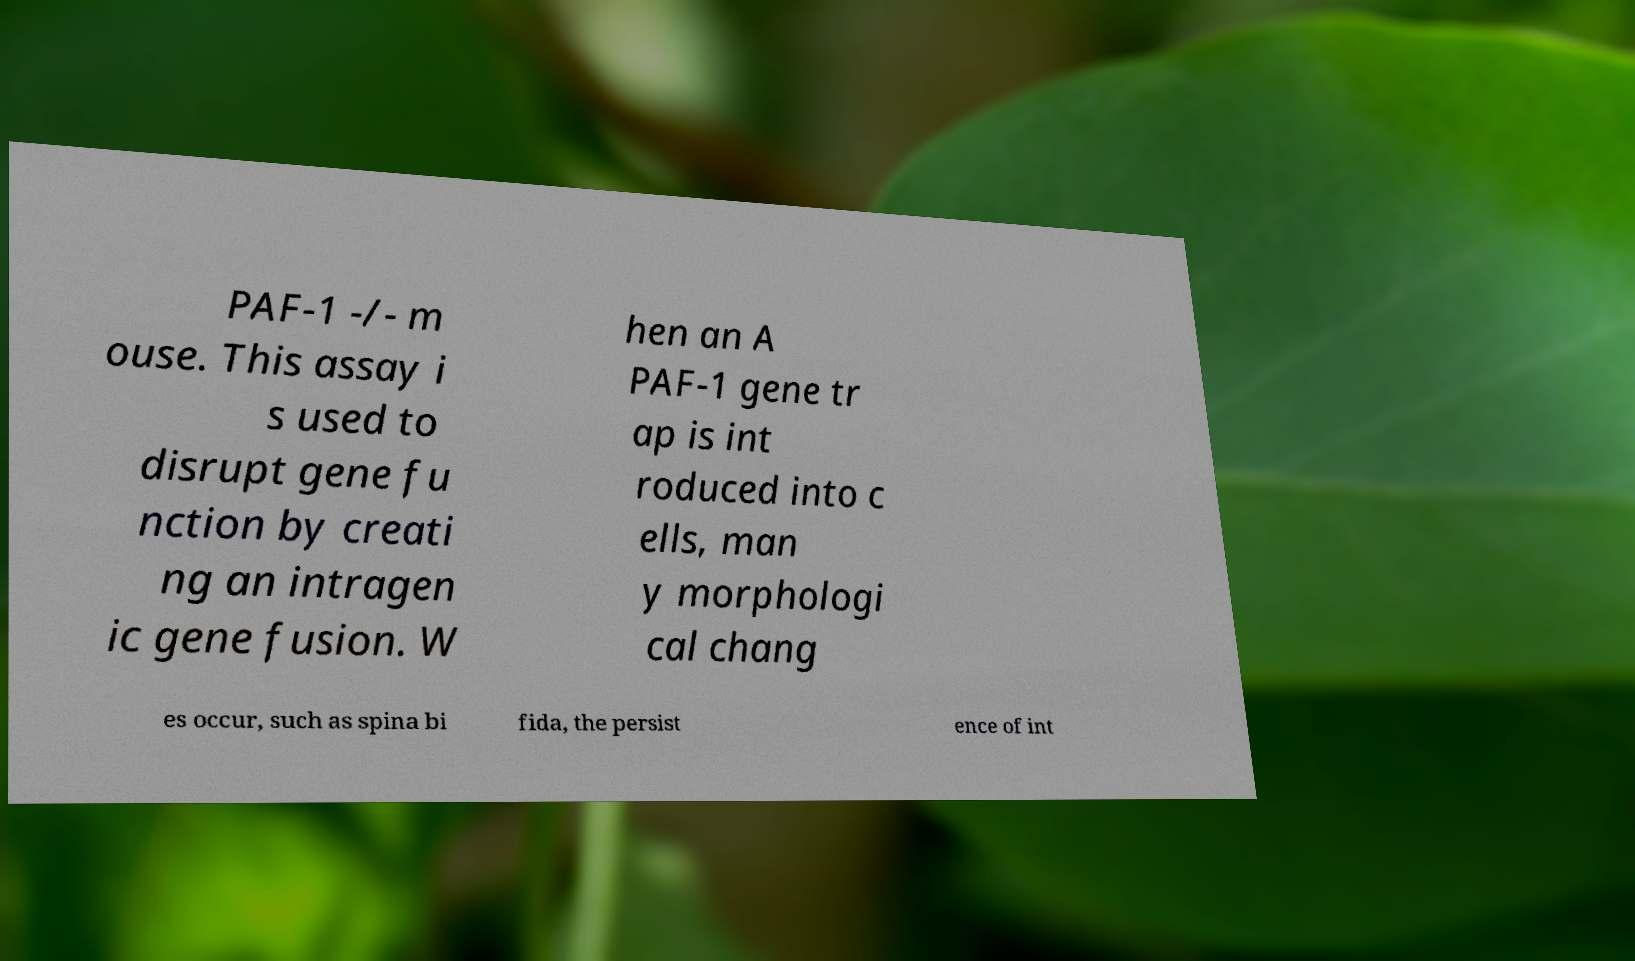Can you read and provide the text displayed in the image?This photo seems to have some interesting text. Can you extract and type it out for me? PAF-1 -/- m ouse. This assay i s used to disrupt gene fu nction by creati ng an intragen ic gene fusion. W hen an A PAF-1 gene tr ap is int roduced into c ells, man y morphologi cal chang es occur, such as spina bi fida, the persist ence of int 